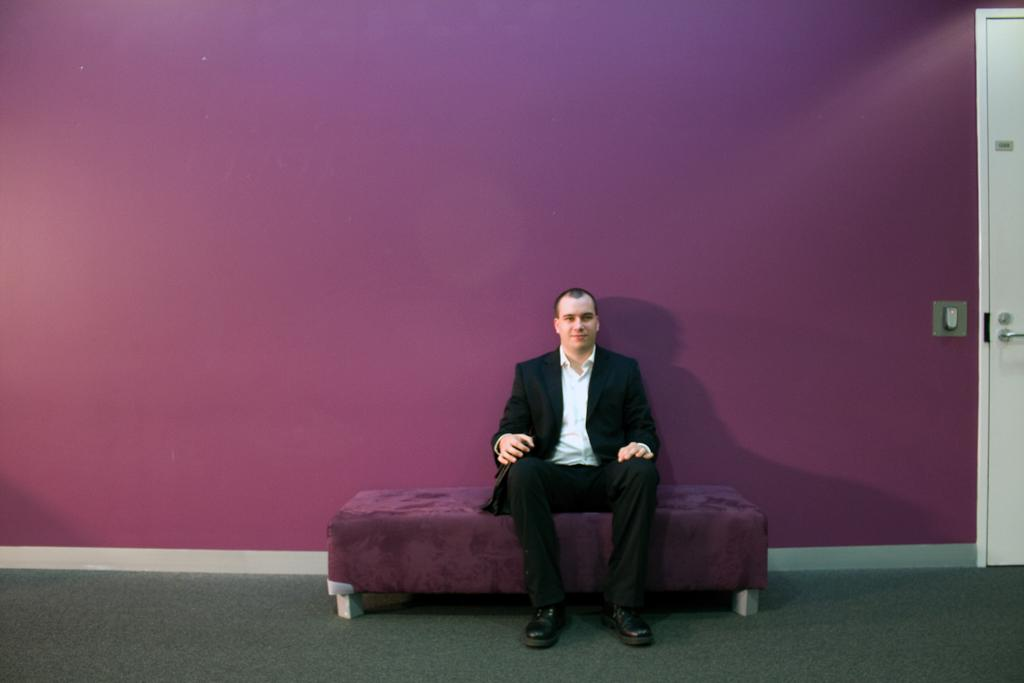Who or what is present in the image? There is a person in the image. What is the person wearing? The person is wearing a black color suit. Where is the person located in the image? The person is sitting on a bed. What color is the wall in the background of the image? The wall in the background of the image is pink color. What type of kettle can be seen in the image? There is no kettle present in the image. Can you tell me how many trucks are visible in the image? There are no trucks visible in the image. 